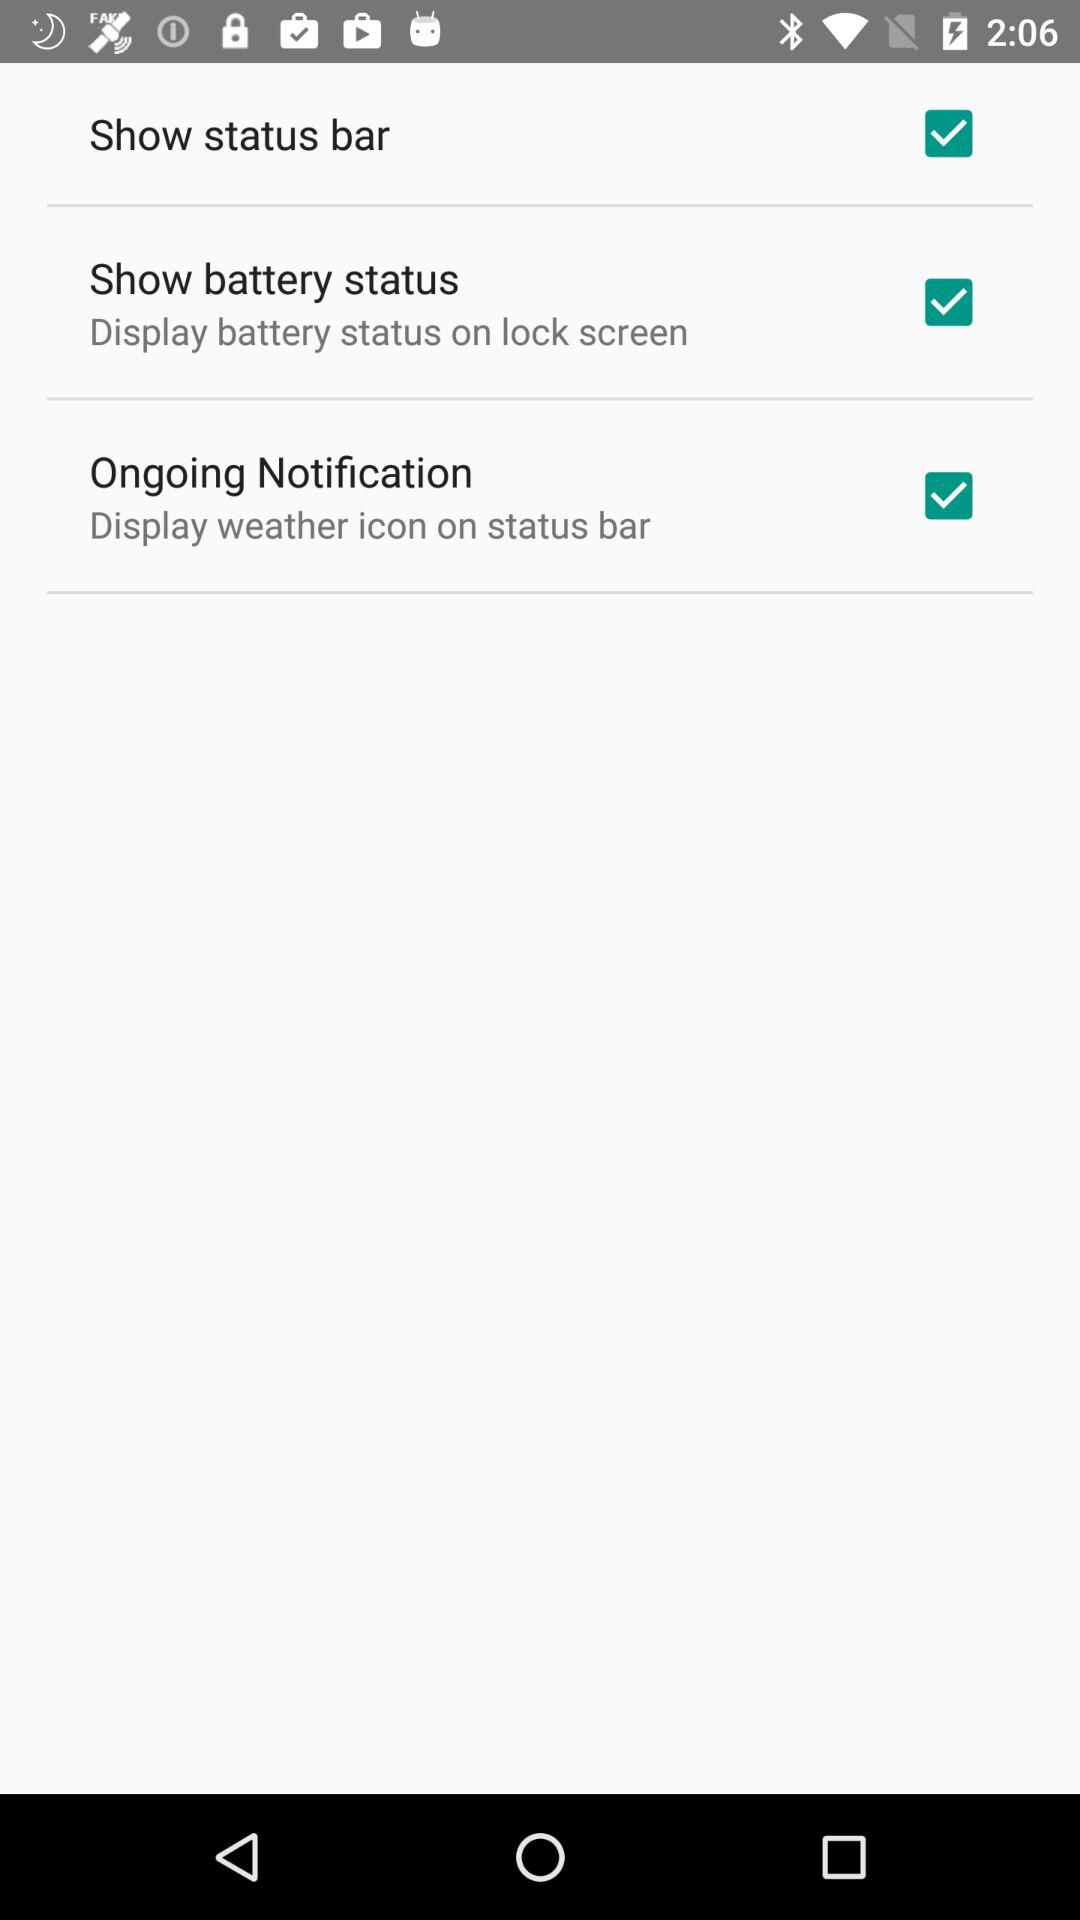What is the status of "Show battery status"? The status of "Show battery status" is "on". 